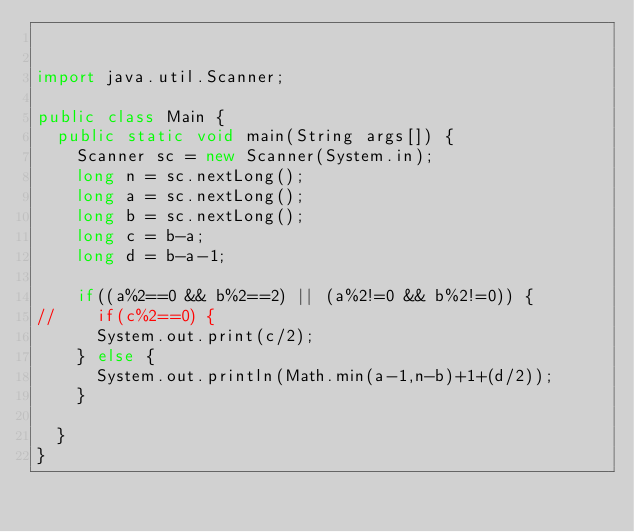Convert code to text. <code><loc_0><loc_0><loc_500><loc_500><_Java_>

import java.util.Scanner;

public class Main {
	public static void main(String args[]) {
		Scanner sc = new Scanner(System.in);
		long n = sc.nextLong();
		long a = sc.nextLong();
		long b = sc.nextLong();
		long c = b-a;
		long d = b-a-1;

		if((a%2==0 && b%2==2) || (a%2!=0 && b%2!=0)) {
//		if(c%2==0) {
			System.out.print(c/2);
		} else {
			System.out.println(Math.min(a-1,n-b)+1+(d/2));
		}

	}
}
</code> 